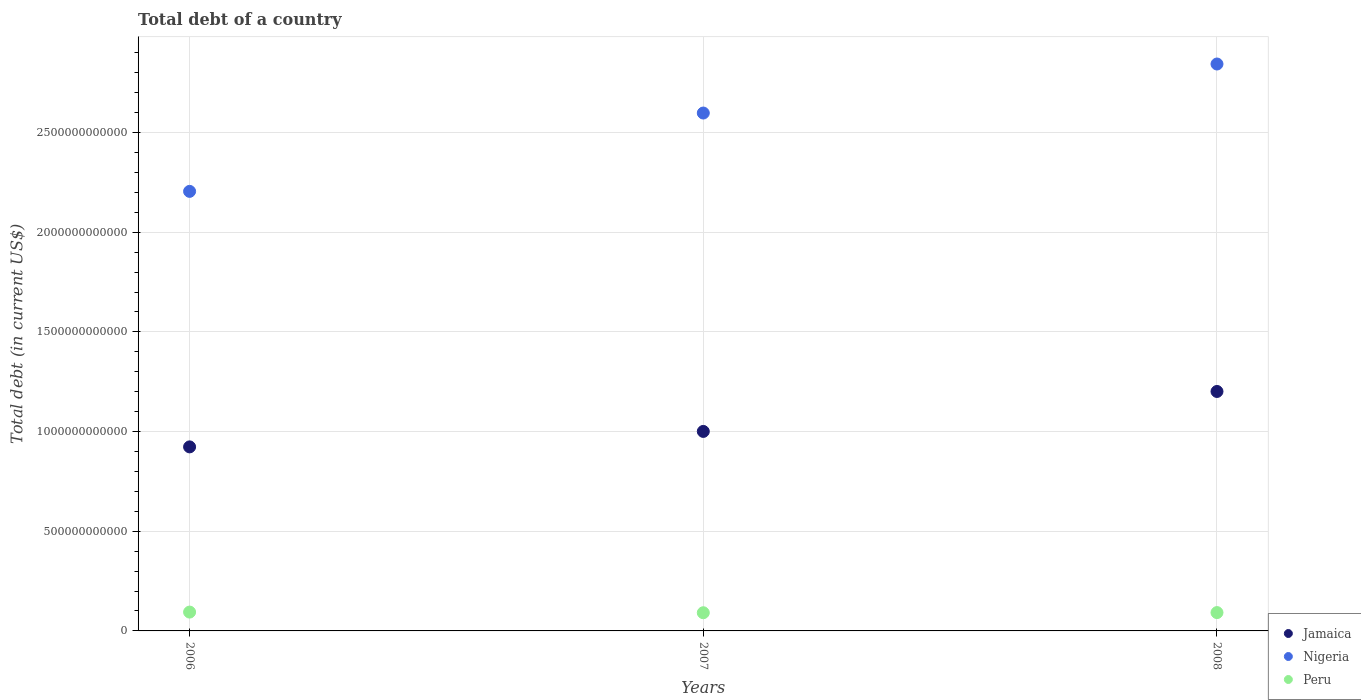How many different coloured dotlines are there?
Offer a terse response. 3. Is the number of dotlines equal to the number of legend labels?
Your response must be concise. Yes. What is the debt in Nigeria in 2007?
Your response must be concise. 2.60e+12. Across all years, what is the maximum debt in Jamaica?
Provide a short and direct response. 1.20e+12. Across all years, what is the minimum debt in Nigeria?
Your answer should be compact. 2.20e+12. What is the total debt in Peru in the graph?
Your response must be concise. 2.78e+11. What is the difference between the debt in Jamaica in 2006 and that in 2008?
Your answer should be very brief. -2.78e+11. What is the difference between the debt in Jamaica in 2006 and the debt in Nigeria in 2008?
Your response must be concise. -1.92e+12. What is the average debt in Nigeria per year?
Provide a short and direct response. 2.55e+12. In the year 2006, what is the difference between the debt in Peru and debt in Nigeria?
Provide a succinct answer. -2.11e+12. What is the ratio of the debt in Nigeria in 2006 to that in 2008?
Your answer should be very brief. 0.78. Is the debt in Nigeria in 2006 less than that in 2008?
Your answer should be compact. Yes. Is the difference between the debt in Peru in 2006 and 2008 greater than the difference between the debt in Nigeria in 2006 and 2008?
Your answer should be very brief. Yes. What is the difference between the highest and the second highest debt in Peru?
Your answer should be compact. 2.48e+09. What is the difference between the highest and the lowest debt in Peru?
Keep it short and to the point. 3.25e+09. Is the sum of the debt in Jamaica in 2006 and 2008 greater than the maximum debt in Peru across all years?
Provide a succinct answer. Yes. Is it the case that in every year, the sum of the debt in Jamaica and debt in Nigeria  is greater than the debt in Peru?
Make the answer very short. Yes. Does the debt in Jamaica monotonically increase over the years?
Keep it short and to the point. Yes. Is the debt in Nigeria strictly greater than the debt in Peru over the years?
Your answer should be very brief. Yes. Is the debt in Jamaica strictly less than the debt in Peru over the years?
Give a very brief answer. No. How many years are there in the graph?
Offer a very short reply. 3. What is the difference between two consecutive major ticks on the Y-axis?
Provide a succinct answer. 5.00e+11. Are the values on the major ticks of Y-axis written in scientific E-notation?
Provide a short and direct response. No. Does the graph contain grids?
Your answer should be compact. Yes. Where does the legend appear in the graph?
Give a very brief answer. Bottom right. What is the title of the graph?
Provide a succinct answer. Total debt of a country. Does "Cayman Islands" appear as one of the legend labels in the graph?
Offer a very short reply. No. What is the label or title of the Y-axis?
Give a very brief answer. Total debt (in current US$). What is the Total debt (in current US$) of Jamaica in 2006?
Offer a terse response. 9.23e+11. What is the Total debt (in current US$) in Nigeria in 2006?
Make the answer very short. 2.20e+12. What is the Total debt (in current US$) of Peru in 2006?
Your response must be concise. 9.45e+1. What is the Total debt (in current US$) of Jamaica in 2007?
Your response must be concise. 1.00e+12. What is the Total debt (in current US$) in Nigeria in 2007?
Offer a very short reply. 2.60e+12. What is the Total debt (in current US$) of Peru in 2007?
Offer a terse response. 9.12e+1. What is the Total debt (in current US$) of Jamaica in 2008?
Keep it short and to the point. 1.20e+12. What is the Total debt (in current US$) of Nigeria in 2008?
Ensure brevity in your answer.  2.84e+12. What is the Total debt (in current US$) in Peru in 2008?
Keep it short and to the point. 9.20e+1. Across all years, what is the maximum Total debt (in current US$) in Jamaica?
Provide a short and direct response. 1.20e+12. Across all years, what is the maximum Total debt (in current US$) in Nigeria?
Provide a short and direct response. 2.84e+12. Across all years, what is the maximum Total debt (in current US$) of Peru?
Offer a terse response. 9.45e+1. Across all years, what is the minimum Total debt (in current US$) in Jamaica?
Provide a succinct answer. 9.23e+11. Across all years, what is the minimum Total debt (in current US$) in Nigeria?
Your answer should be very brief. 2.20e+12. Across all years, what is the minimum Total debt (in current US$) of Peru?
Your response must be concise. 9.12e+1. What is the total Total debt (in current US$) of Jamaica in the graph?
Offer a very short reply. 3.12e+12. What is the total Total debt (in current US$) of Nigeria in the graph?
Your answer should be very brief. 7.65e+12. What is the total Total debt (in current US$) of Peru in the graph?
Ensure brevity in your answer.  2.78e+11. What is the difference between the Total debt (in current US$) in Jamaica in 2006 and that in 2007?
Make the answer very short. -7.76e+1. What is the difference between the Total debt (in current US$) in Nigeria in 2006 and that in 2007?
Offer a very short reply. -3.93e+11. What is the difference between the Total debt (in current US$) of Peru in 2006 and that in 2007?
Your response must be concise. 3.25e+09. What is the difference between the Total debt (in current US$) of Jamaica in 2006 and that in 2008?
Offer a terse response. -2.78e+11. What is the difference between the Total debt (in current US$) of Nigeria in 2006 and that in 2008?
Your answer should be very brief. -6.39e+11. What is the difference between the Total debt (in current US$) of Peru in 2006 and that in 2008?
Offer a terse response. 2.48e+09. What is the difference between the Total debt (in current US$) in Jamaica in 2007 and that in 2008?
Give a very brief answer. -2.00e+11. What is the difference between the Total debt (in current US$) in Nigeria in 2007 and that in 2008?
Keep it short and to the point. -2.46e+11. What is the difference between the Total debt (in current US$) of Peru in 2007 and that in 2008?
Offer a very short reply. -7.72e+08. What is the difference between the Total debt (in current US$) of Jamaica in 2006 and the Total debt (in current US$) of Nigeria in 2007?
Offer a terse response. -1.67e+12. What is the difference between the Total debt (in current US$) of Jamaica in 2006 and the Total debt (in current US$) of Peru in 2007?
Your response must be concise. 8.32e+11. What is the difference between the Total debt (in current US$) in Nigeria in 2006 and the Total debt (in current US$) in Peru in 2007?
Your response must be concise. 2.11e+12. What is the difference between the Total debt (in current US$) of Jamaica in 2006 and the Total debt (in current US$) of Nigeria in 2008?
Keep it short and to the point. -1.92e+12. What is the difference between the Total debt (in current US$) of Jamaica in 2006 and the Total debt (in current US$) of Peru in 2008?
Make the answer very short. 8.31e+11. What is the difference between the Total debt (in current US$) of Nigeria in 2006 and the Total debt (in current US$) of Peru in 2008?
Your response must be concise. 2.11e+12. What is the difference between the Total debt (in current US$) in Jamaica in 2007 and the Total debt (in current US$) in Nigeria in 2008?
Offer a terse response. -1.84e+12. What is the difference between the Total debt (in current US$) in Jamaica in 2007 and the Total debt (in current US$) in Peru in 2008?
Offer a very short reply. 9.09e+11. What is the difference between the Total debt (in current US$) in Nigeria in 2007 and the Total debt (in current US$) in Peru in 2008?
Provide a short and direct response. 2.51e+12. What is the average Total debt (in current US$) in Jamaica per year?
Keep it short and to the point. 1.04e+12. What is the average Total debt (in current US$) of Nigeria per year?
Your response must be concise. 2.55e+12. What is the average Total debt (in current US$) in Peru per year?
Keep it short and to the point. 9.25e+1. In the year 2006, what is the difference between the Total debt (in current US$) in Jamaica and Total debt (in current US$) in Nigeria?
Give a very brief answer. -1.28e+12. In the year 2006, what is the difference between the Total debt (in current US$) in Jamaica and Total debt (in current US$) in Peru?
Make the answer very short. 8.29e+11. In the year 2006, what is the difference between the Total debt (in current US$) of Nigeria and Total debt (in current US$) of Peru?
Ensure brevity in your answer.  2.11e+12. In the year 2007, what is the difference between the Total debt (in current US$) of Jamaica and Total debt (in current US$) of Nigeria?
Keep it short and to the point. -1.60e+12. In the year 2007, what is the difference between the Total debt (in current US$) of Jamaica and Total debt (in current US$) of Peru?
Ensure brevity in your answer.  9.09e+11. In the year 2007, what is the difference between the Total debt (in current US$) in Nigeria and Total debt (in current US$) in Peru?
Your response must be concise. 2.51e+12. In the year 2008, what is the difference between the Total debt (in current US$) of Jamaica and Total debt (in current US$) of Nigeria?
Keep it short and to the point. -1.64e+12. In the year 2008, what is the difference between the Total debt (in current US$) of Jamaica and Total debt (in current US$) of Peru?
Ensure brevity in your answer.  1.11e+12. In the year 2008, what is the difference between the Total debt (in current US$) in Nigeria and Total debt (in current US$) in Peru?
Your answer should be compact. 2.75e+12. What is the ratio of the Total debt (in current US$) in Jamaica in 2006 to that in 2007?
Ensure brevity in your answer.  0.92. What is the ratio of the Total debt (in current US$) in Nigeria in 2006 to that in 2007?
Offer a terse response. 0.85. What is the ratio of the Total debt (in current US$) of Peru in 2006 to that in 2007?
Provide a succinct answer. 1.04. What is the ratio of the Total debt (in current US$) of Jamaica in 2006 to that in 2008?
Make the answer very short. 0.77. What is the ratio of the Total debt (in current US$) in Nigeria in 2006 to that in 2008?
Your answer should be very brief. 0.78. What is the ratio of the Total debt (in current US$) of Peru in 2006 to that in 2008?
Provide a succinct answer. 1.03. What is the ratio of the Total debt (in current US$) of Jamaica in 2007 to that in 2008?
Provide a short and direct response. 0.83. What is the ratio of the Total debt (in current US$) in Nigeria in 2007 to that in 2008?
Offer a very short reply. 0.91. What is the ratio of the Total debt (in current US$) of Peru in 2007 to that in 2008?
Your answer should be compact. 0.99. What is the difference between the highest and the second highest Total debt (in current US$) in Jamaica?
Offer a terse response. 2.00e+11. What is the difference between the highest and the second highest Total debt (in current US$) in Nigeria?
Make the answer very short. 2.46e+11. What is the difference between the highest and the second highest Total debt (in current US$) of Peru?
Give a very brief answer. 2.48e+09. What is the difference between the highest and the lowest Total debt (in current US$) in Jamaica?
Your answer should be very brief. 2.78e+11. What is the difference between the highest and the lowest Total debt (in current US$) in Nigeria?
Your answer should be very brief. 6.39e+11. What is the difference between the highest and the lowest Total debt (in current US$) in Peru?
Make the answer very short. 3.25e+09. 